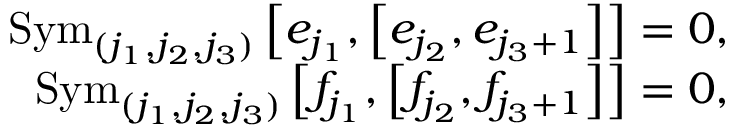<formula> <loc_0><loc_0><loc_500><loc_500>\begin{array} { r l r } & { S y m _ { ( j _ { 1 } , j _ { 2 } , j _ { 3 } ) } \left [ e _ { j _ { 1 } } , \left [ e _ { j _ { 2 } } , e _ { j _ { 3 } + 1 } \right ] \right ] = 0 , } \\ & { S y m _ { ( j _ { 1 } , j _ { 2 } , j _ { 3 } ) } \left [ f _ { j _ { 1 } } , \left [ f _ { j _ { 2 } } , f _ { j _ { 3 } + 1 } \right ] \right ] = 0 , } \end{array}</formula> 